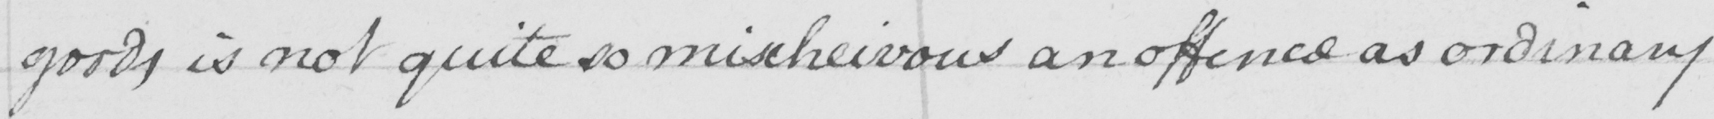What does this handwritten line say? goods is not quite so mischievous an offence as ordinary 